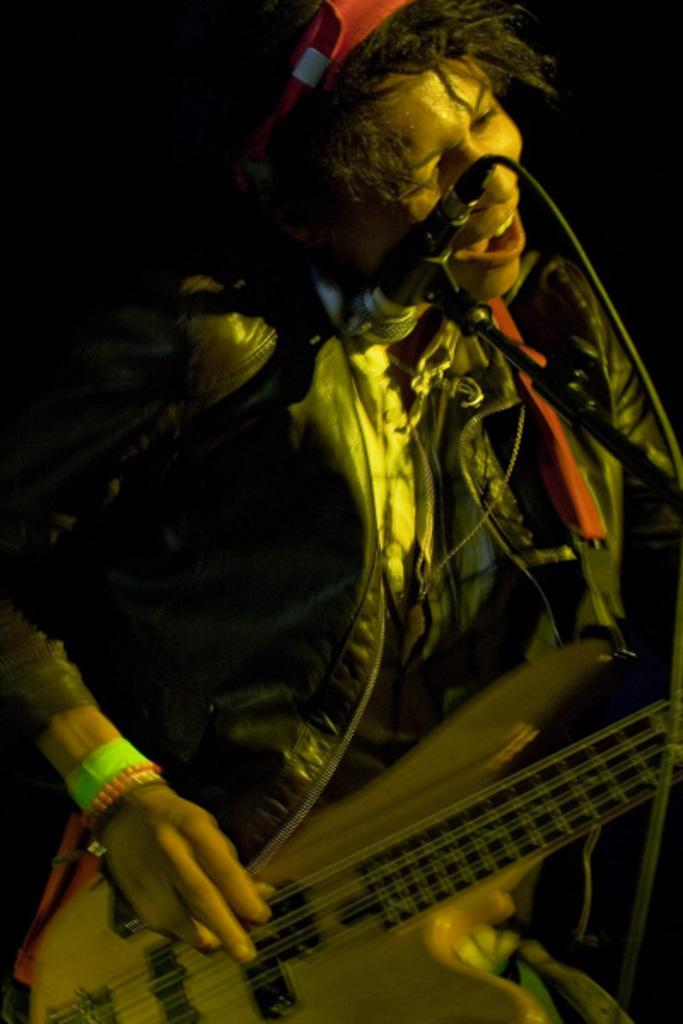What is the person in the image doing? The person is holding a guitar. What object is present in the image that is commonly used for amplifying sound? There is a microphone in the image. What can be seen in the image that might be used to support or hold something? There is a stand in the image. Is there a woman in the office playing with a ball in the image? There is no woman, office, or ball present in the image. 